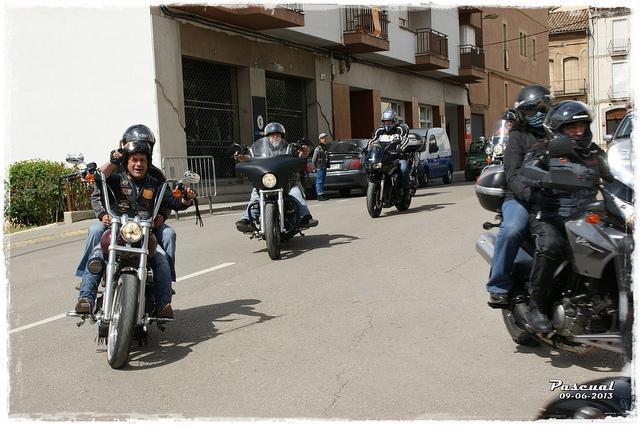How many people can be seen?
Give a very brief answer. 4. How many motorcycles are in the photo?
Give a very brief answer. 4. 